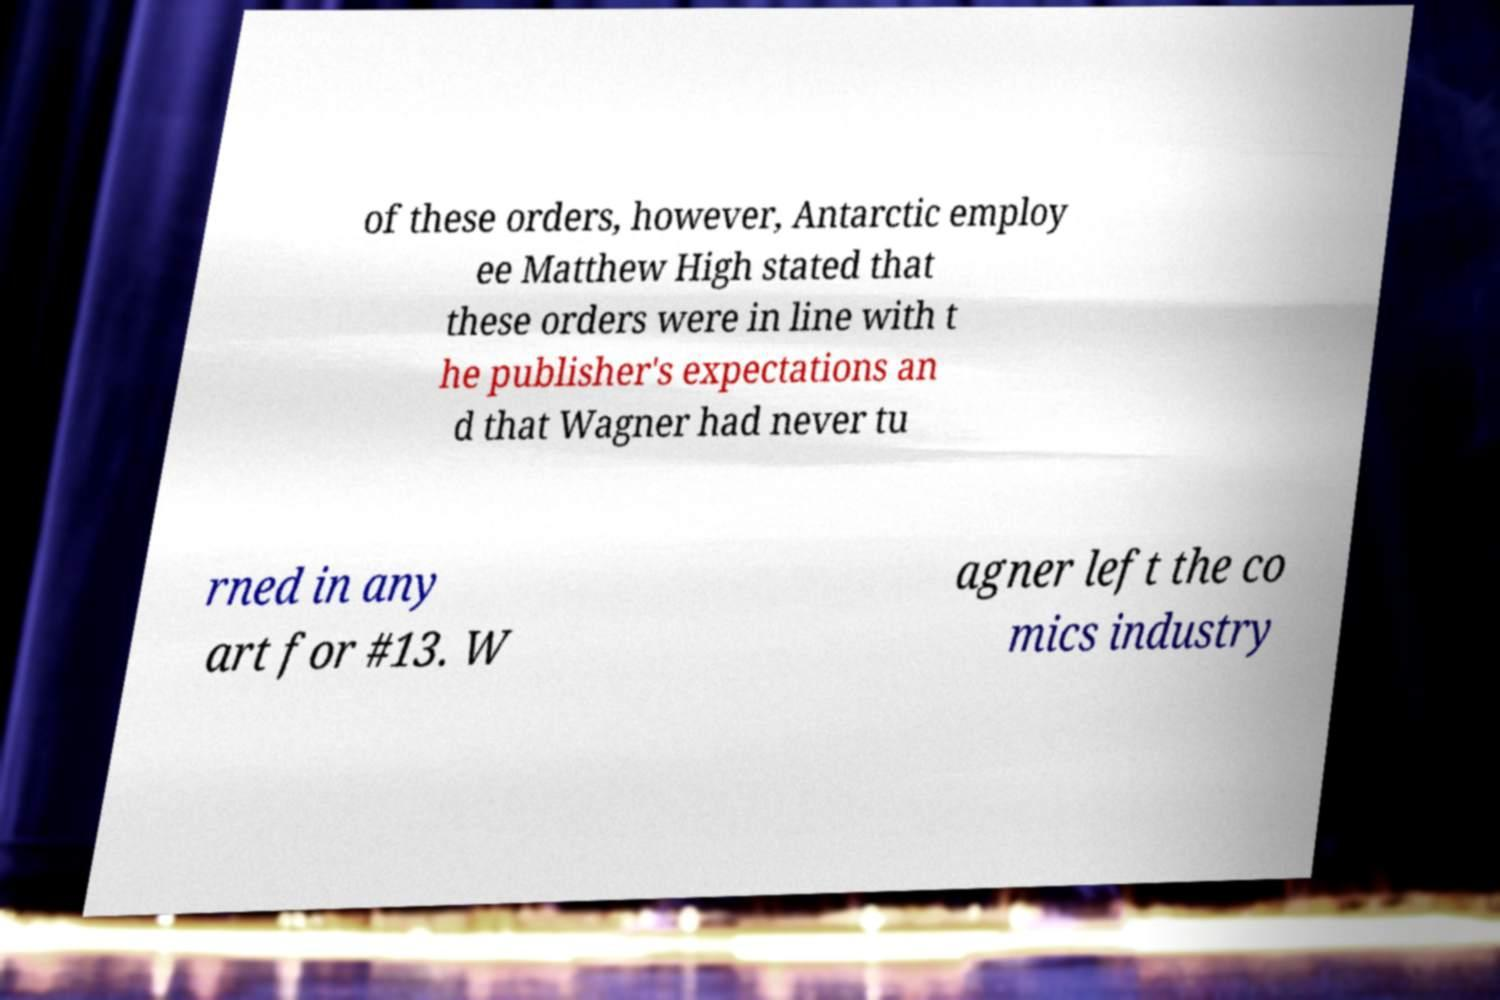Can you accurately transcribe the text from the provided image for me? of these orders, however, Antarctic employ ee Matthew High stated that these orders were in line with t he publisher's expectations an d that Wagner had never tu rned in any art for #13. W agner left the co mics industry 